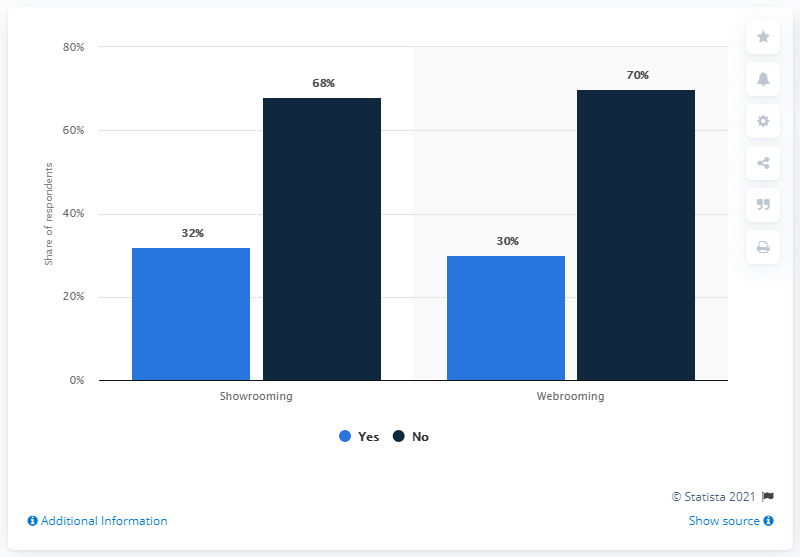Draw attention to some important aspects in this diagram. The average score for "yes" on web rooming and show rooming is 31. The color blue, specifically light blue, indicates a yes response. 